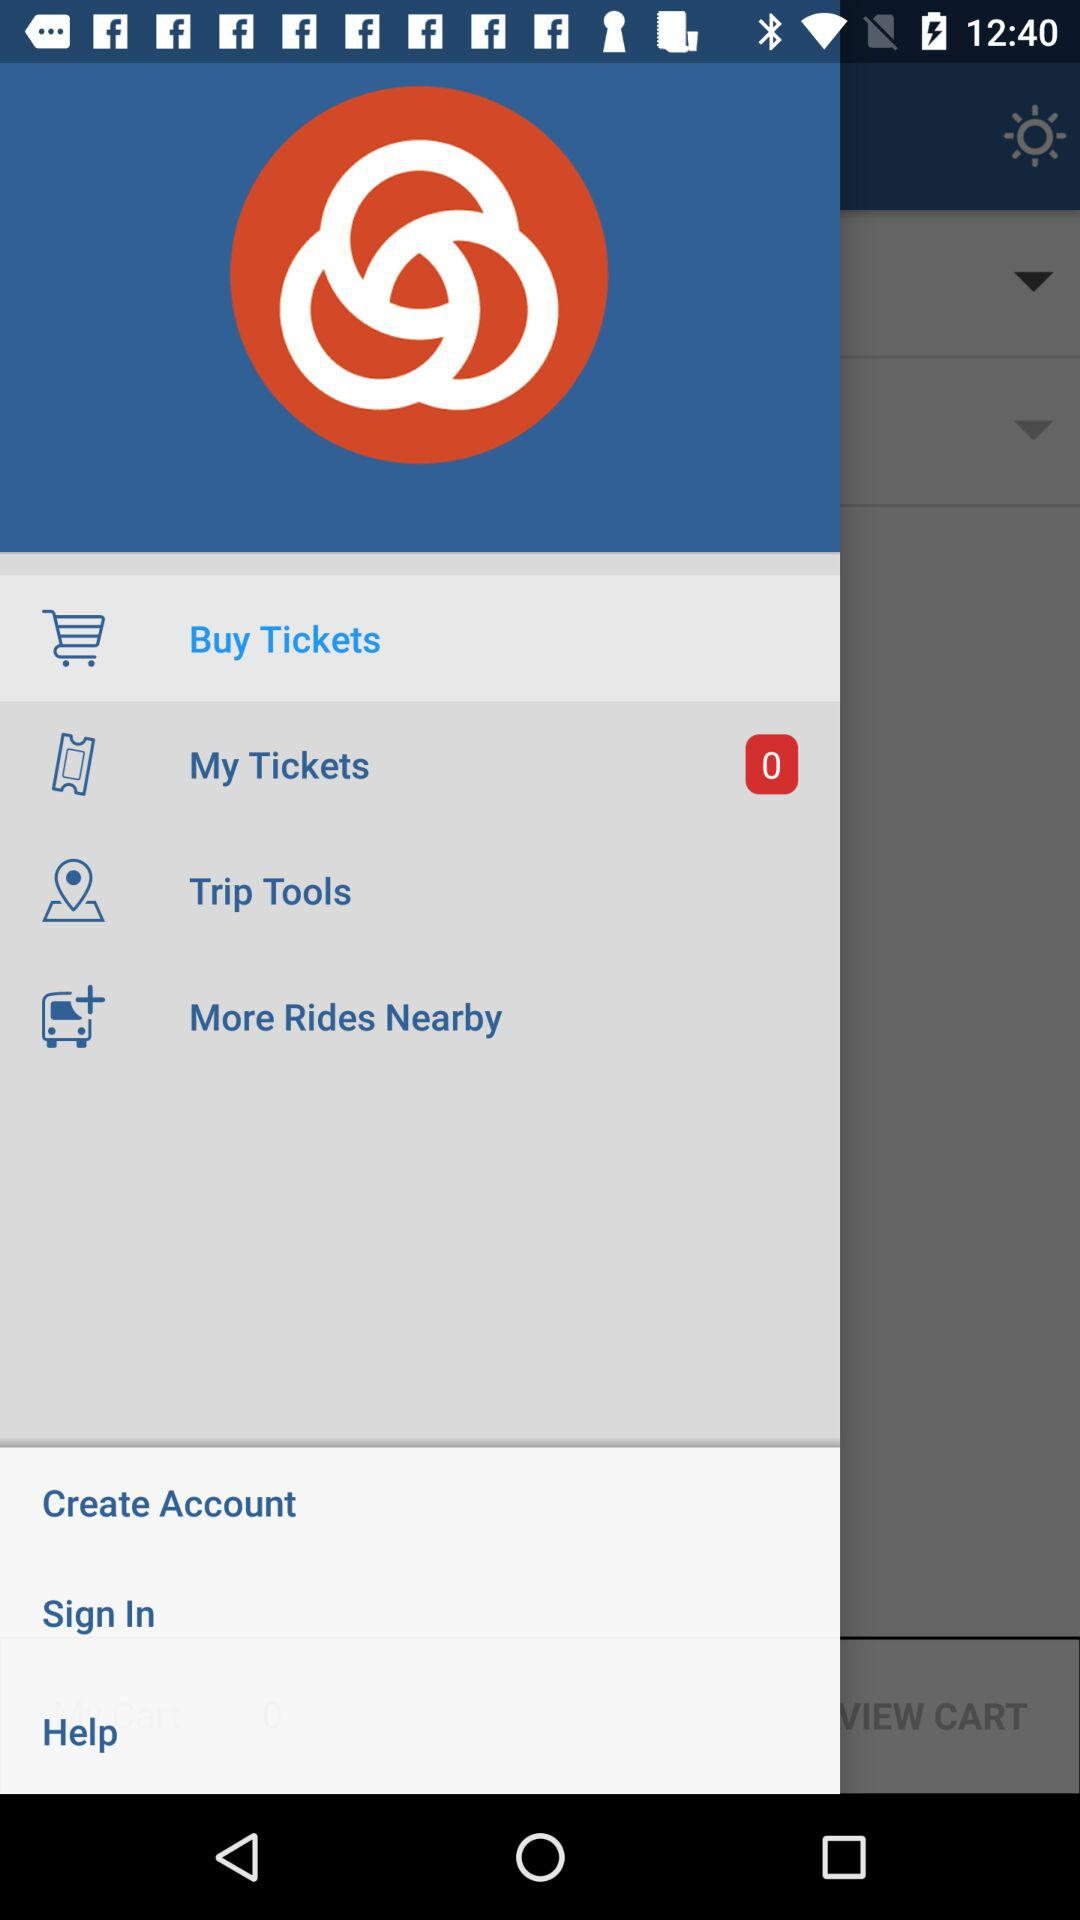How many tickets are shown? There are zero tickets. 